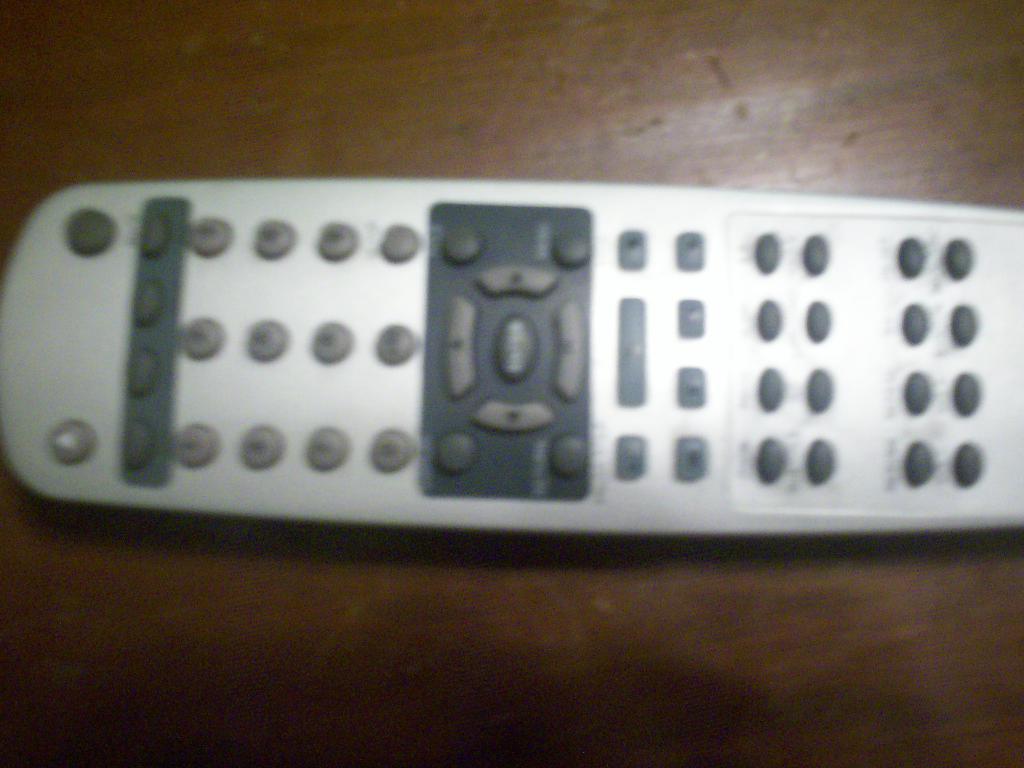In one or two sentences, can you explain what this image depicts? In this picture there is a remote and there are buttons with numbers on the remote. At the bottom there is a wooden floor. 